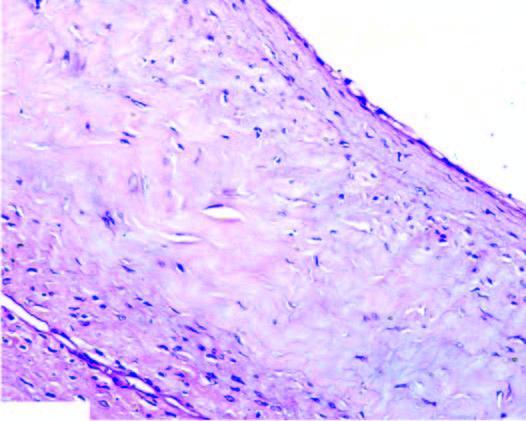s the cyst wall composed of dense connective tissue lined internally by flattened lining?
Answer the question using a single word or phrase. Yes 